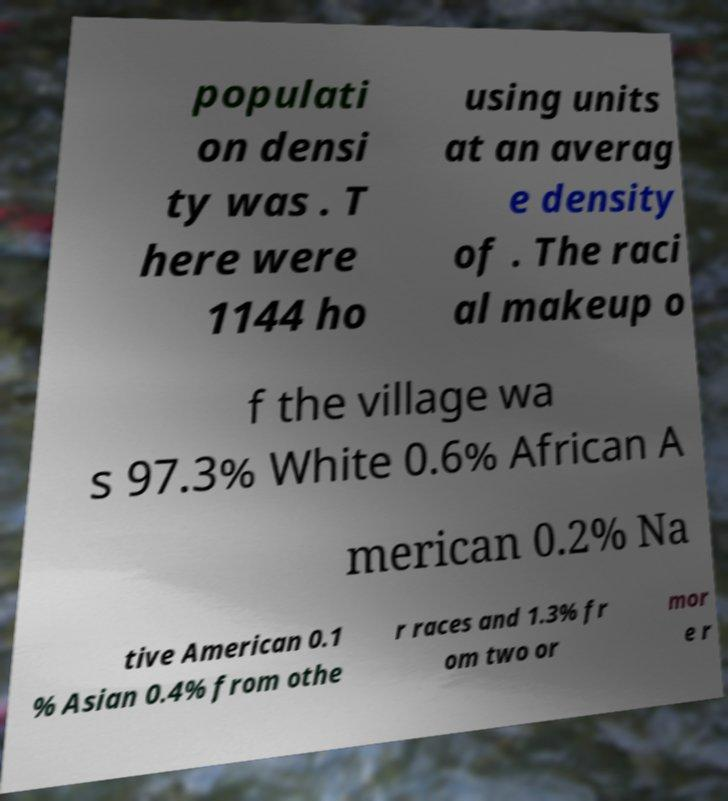What messages or text are displayed in this image? I need them in a readable, typed format. populati on densi ty was . T here were 1144 ho using units at an averag e density of . The raci al makeup o f the village wa s 97.3% White 0.6% African A merican 0.2% Na tive American 0.1 % Asian 0.4% from othe r races and 1.3% fr om two or mor e r 